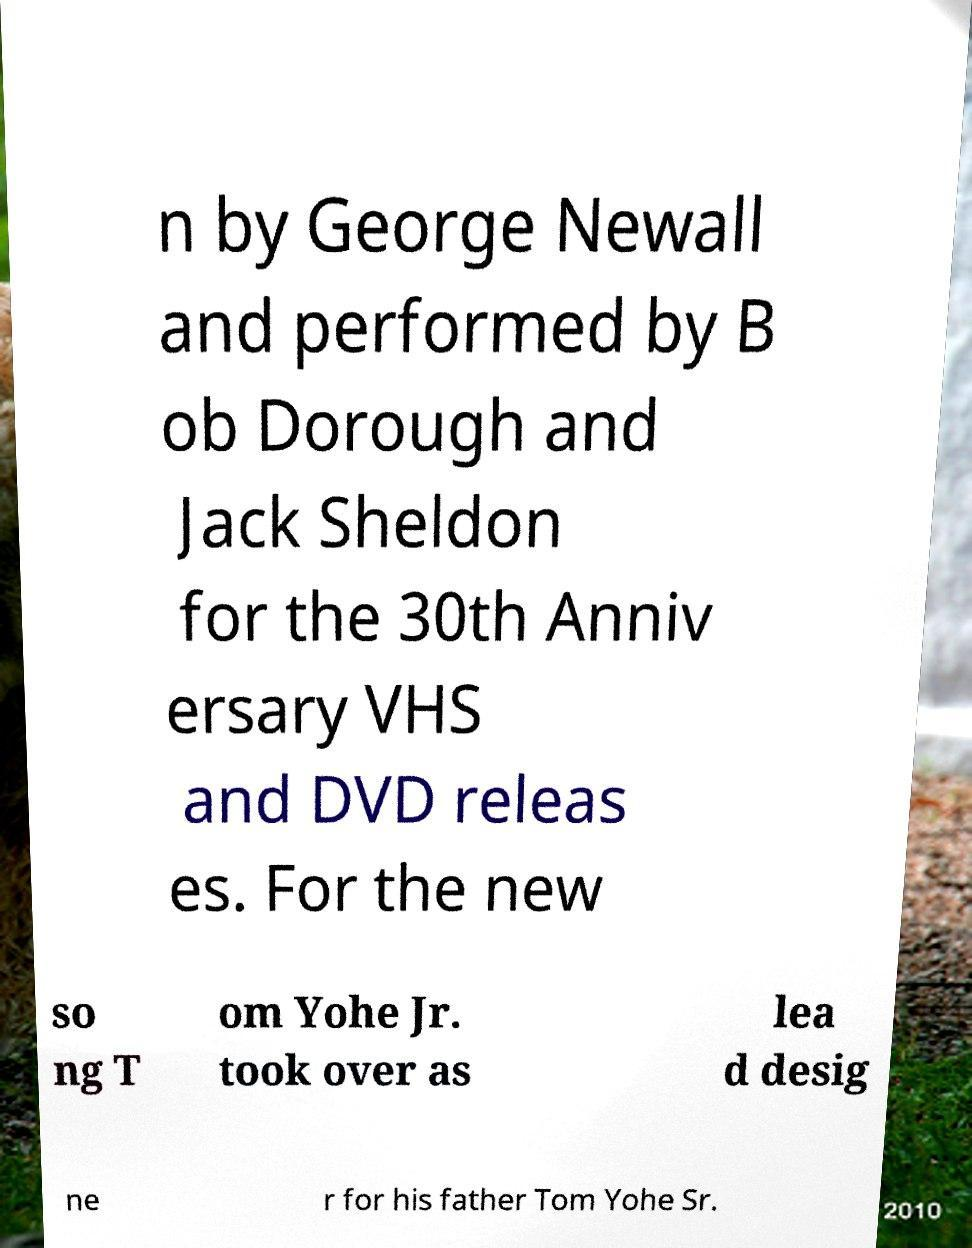For documentation purposes, I need the text within this image transcribed. Could you provide that? n by George Newall and performed by B ob Dorough and Jack Sheldon for the 30th Anniv ersary VHS and DVD releas es. For the new so ng T om Yohe Jr. took over as lea d desig ne r for his father Tom Yohe Sr. 